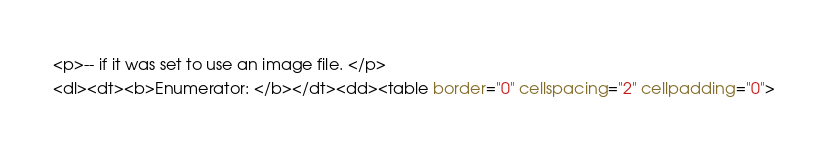Convert code to text. <code><loc_0><loc_0><loc_500><loc_500><_HTML_><p>-- if it was set to use an image file. </p>
<dl><dt><b>Enumerator: </b></dt><dd><table border="0" cellspacing="2" cellpadding="0"></code> 